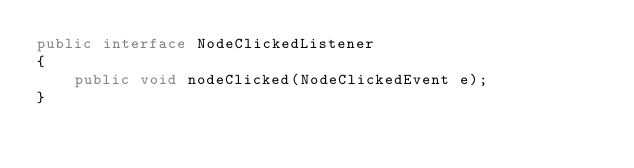Convert code to text. <code><loc_0><loc_0><loc_500><loc_500><_Java_>public interface NodeClickedListener
{
    public void nodeClicked(NodeClickedEvent e);
}
</code> 